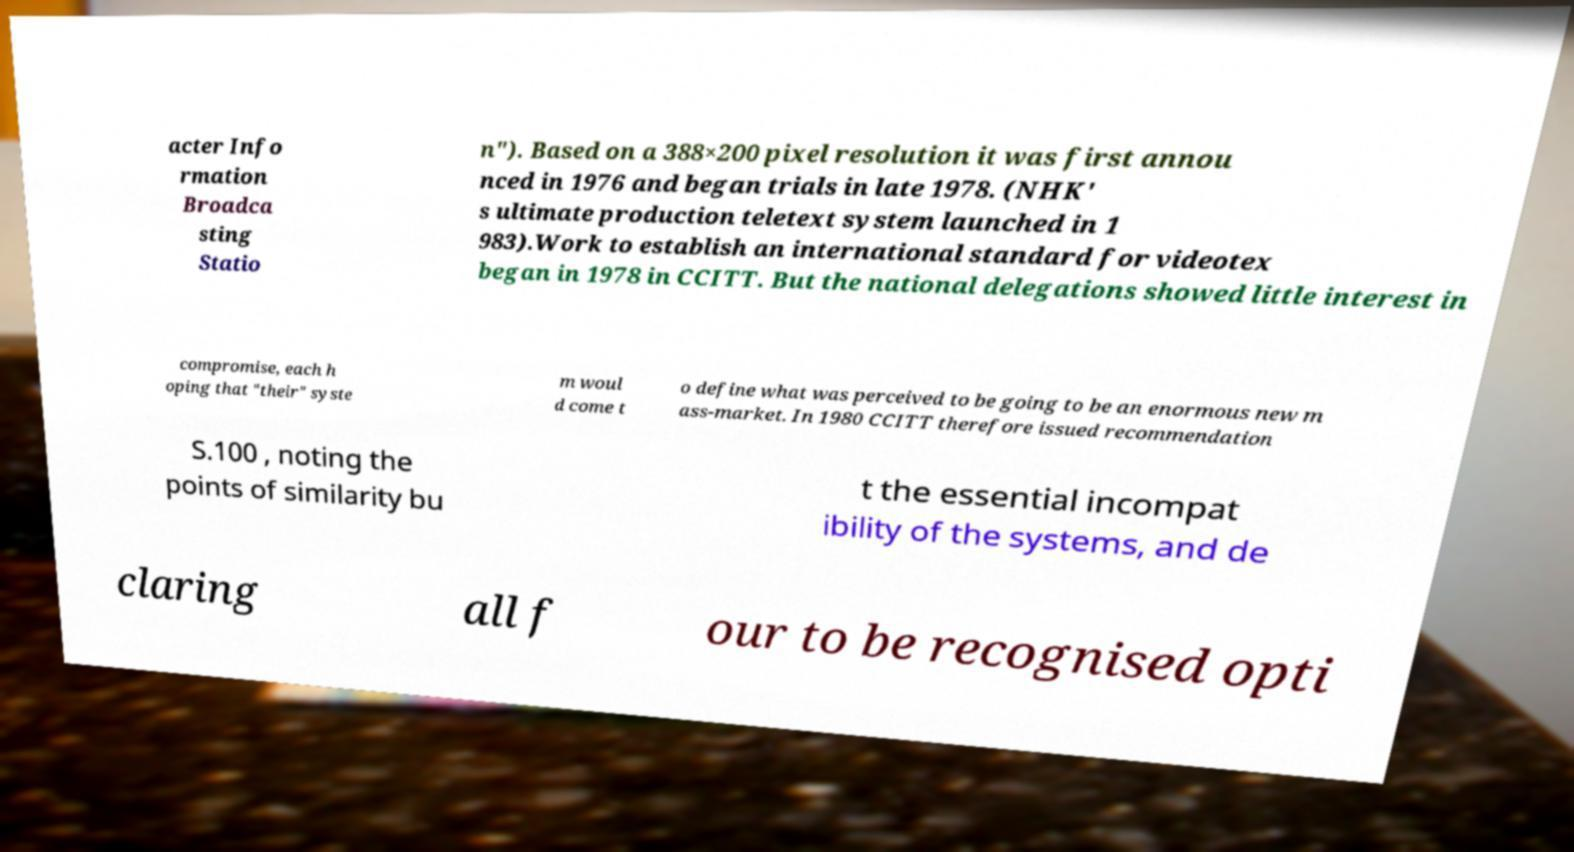I need the written content from this picture converted into text. Can you do that? acter Info rmation Broadca sting Statio n"). Based on a 388×200 pixel resolution it was first annou nced in 1976 and began trials in late 1978. (NHK' s ultimate production teletext system launched in 1 983).Work to establish an international standard for videotex began in 1978 in CCITT. But the national delegations showed little interest in compromise, each h oping that "their" syste m woul d come t o define what was perceived to be going to be an enormous new m ass-market. In 1980 CCITT therefore issued recommendation S.100 , noting the points of similarity bu t the essential incompat ibility of the systems, and de claring all f our to be recognised opti 